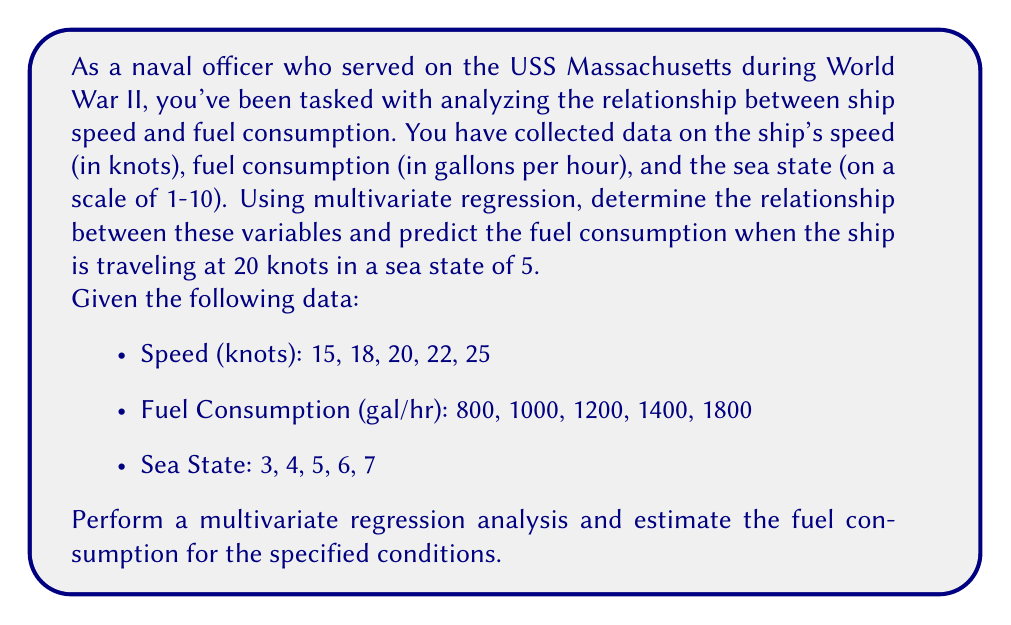Can you answer this question? To solve this problem, we'll use multivariate linear regression with two independent variables (speed and sea state) and one dependent variable (fuel consumption). Let's follow these steps:

1) First, we'll set up our regression equation:

   $$ \text{Fuel Consumption} = \beta_0 + \beta_1 \cdot \text{Speed} + \beta_2 \cdot \text{Sea State} + \epsilon $$

   Where $\beta_0$ is the intercept, $\beta_1$ and $\beta_2$ are the coefficients for Speed and Sea State respectively, and $\epsilon$ is the error term.

2) We'll use matrix notation to solve this regression problem. Let's set up our matrices:

   $$ X = \begin{bmatrix} 
   1 & 15 & 3 \\
   1 & 18 & 4 \\
   1 & 20 & 5 \\
   1 & 22 & 6 \\
   1 & 25 & 7
   \end{bmatrix} $$

   $$ Y = \begin{bmatrix}
   800 \\
   1000 \\
   1200 \\
   1400 \\
   1800
   \end{bmatrix} $$

3) The formula for the coefficients in matrix form is:

   $$ \beta = (X^TX)^{-1}X^TY $$

4) Let's calculate $X^TX$:

   $$ X^TX = \begin{bmatrix}
   5 & 100 & 25 \\
   100 & 2078 & 515 \\
   25 & 515 & 135
   \end{bmatrix} $$

5) Now calculate $(X^TX)^{-1}$:

   $$ (X^TX)^{-1} = \begin{bmatrix}
   12.5 & -0.5 & -0.5 \\
   -0.5 & 0.025 & 0 \\
   -0.5 & 0 & 0.125
   \end{bmatrix} $$

6) Next, calculate $X^TY$:

   $$ X^TY = \begin{bmatrix}
   6200 \\
   129400 \\
   32000
   \end{bmatrix} $$

7) Finally, we can calculate $\beta$:

   $$ \beta = (X^TX)^{-1}X^TY = \begin{bmatrix}
   -1075 \\
   100 \\
   75
   \end{bmatrix} $$

8) This gives us our regression equation:

   $$ \text{Fuel Consumption} = -1075 + 100 \cdot \text{Speed} + 75 \cdot \text{Sea State} $$

9) To predict fuel consumption at 20 knots in a sea state of 5:

   $$ \text{Fuel Consumption} = -1075 + 100(20) + 75(5) = 1300 $$

Therefore, the predicted fuel consumption is 1300 gallons per hour.
Answer: The predicted fuel consumption for the USS Massachusetts traveling at 20 knots in a sea state of 5 is 1300 gallons per hour. 